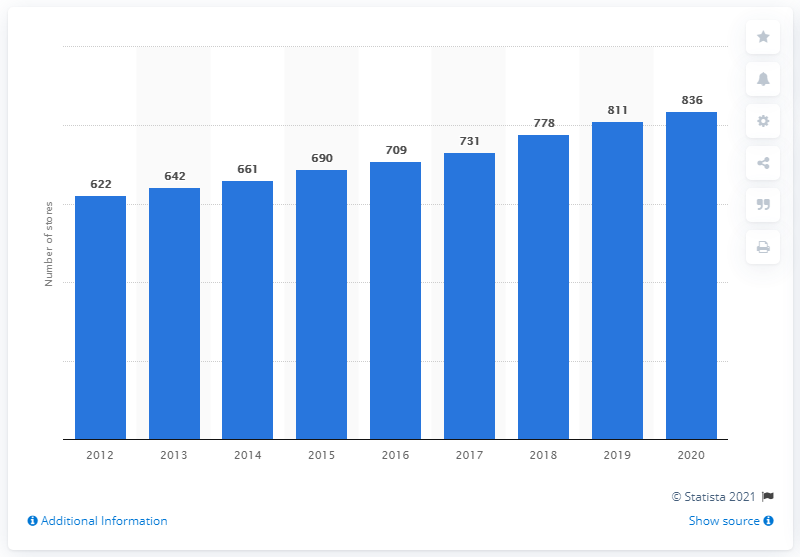Highlight a few significant elements in this photo. Walmart has demonstrated an upward trend in Central America since 2012. In 2020, Walmart had a total of 836 stores in Central America. 